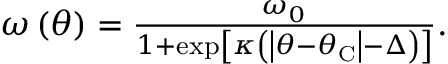<formula> <loc_0><loc_0><loc_500><loc_500>\begin{array} { r } { \omega \left ( \theta \right ) = \frac { \omega _ { 0 } } { 1 + \exp \left [ \kappa \left ( \left | \theta - \theta _ { C } \right | - \Delta \right ) \right ] } . } \end{array}</formula> 